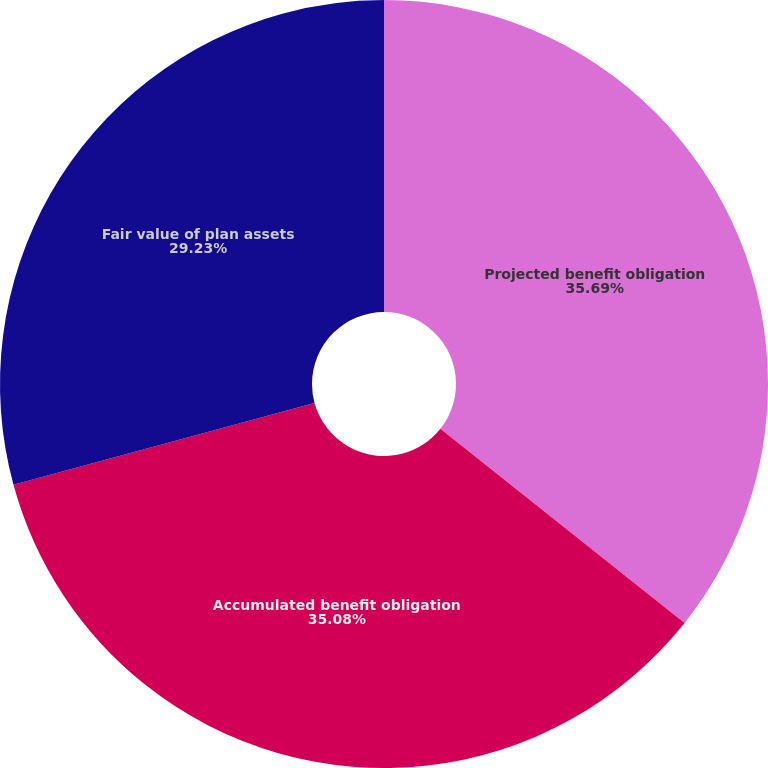Convert chart to OTSL. <chart><loc_0><loc_0><loc_500><loc_500><pie_chart><fcel>Projected benefit obligation<fcel>Accumulated benefit obligation<fcel>Fair value of plan assets<nl><fcel>35.69%<fcel>35.08%<fcel>29.23%<nl></chart> 